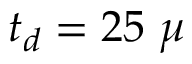Convert formula to latex. <formula><loc_0><loc_0><loc_500><loc_500>t _ { d } = 2 5 \mu</formula> 